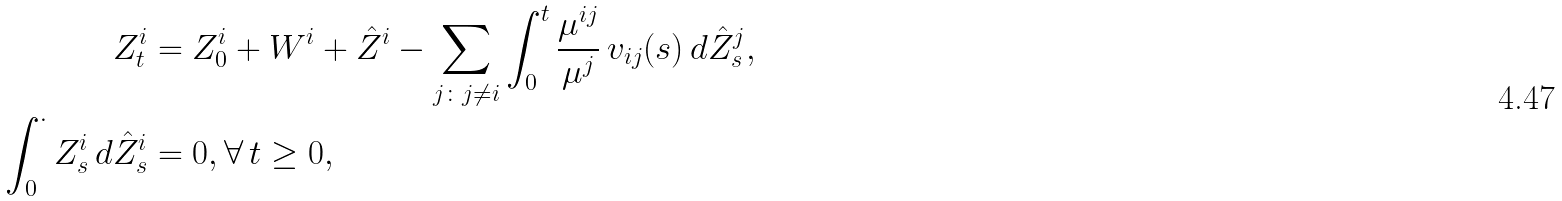<formula> <loc_0><loc_0><loc_500><loc_500>Z ^ { i } _ { t } & = Z ^ { i } _ { 0 } + W ^ { i } + \hat { Z } ^ { i } - \sum _ { j \colon j \neq i } \int _ { 0 } ^ { t } \frac { \mu ^ { i j } } { \mu ^ { j } } \, v _ { i j } ( s ) \, d { \hat { Z } ^ { j } _ { s } } , \\ \int _ { 0 } ^ { \cdot } Z ^ { i } _ { s } \, d { \hat { Z } ^ { i } _ { s } } & = 0 , \forall \, t \geq 0 ,</formula> 